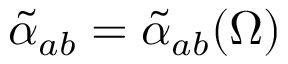<formula> <loc_0><loc_0><loc_500><loc_500>\tilde { \alpha } _ { a b } = \tilde { \alpha } _ { a b } ( \Omega )</formula> 